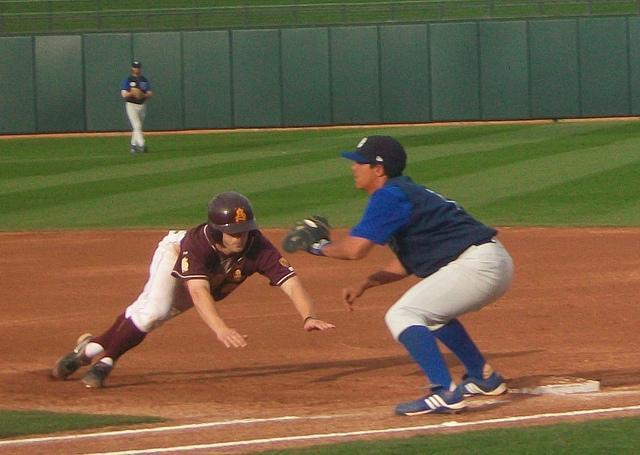How many people are wearing helmets?
Give a very brief answer. 1. How many people are in the photo?
Give a very brief answer. 2. How many coffee cups are in the rack?
Give a very brief answer. 0. 